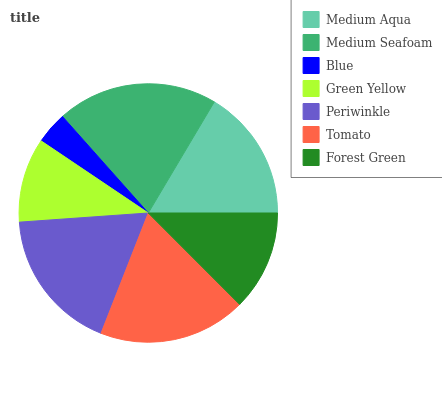Is Blue the minimum?
Answer yes or no. Yes. Is Medium Seafoam the maximum?
Answer yes or no. Yes. Is Medium Seafoam the minimum?
Answer yes or no. No. Is Blue the maximum?
Answer yes or no. No. Is Medium Seafoam greater than Blue?
Answer yes or no. Yes. Is Blue less than Medium Seafoam?
Answer yes or no. Yes. Is Blue greater than Medium Seafoam?
Answer yes or no. No. Is Medium Seafoam less than Blue?
Answer yes or no. No. Is Medium Aqua the high median?
Answer yes or no. Yes. Is Medium Aqua the low median?
Answer yes or no. Yes. Is Green Yellow the high median?
Answer yes or no. No. Is Green Yellow the low median?
Answer yes or no. No. 